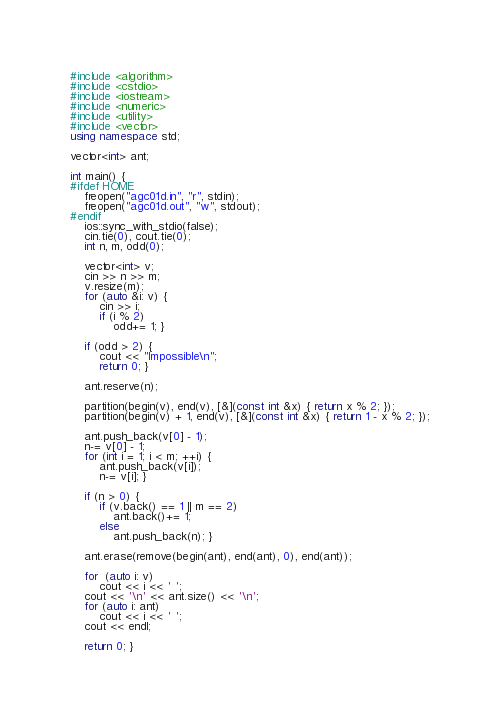Convert code to text. <code><loc_0><loc_0><loc_500><loc_500><_C++_>#include <algorithm>
#include <cstdio>
#include <iostream>
#include <numeric>
#include <utility>
#include <vector>
using namespace std;

vector<int> ant;

int main() {
#ifdef HOME
	freopen("agc01d.in", "r", stdin);
	freopen("agc01d.out", "w", stdout);
#endif
	ios::sync_with_stdio(false);
	cin.tie(0), cout.tie(0);
	int n, m, odd(0);

	vector<int> v;
	cin >> n >> m;
	v.resize(m);
	for (auto &i: v) {
		cin >> i;
		if (i % 2)
			odd+= 1; }

	if (odd > 2) {
		cout << "Impossible\n";
		return 0; }

	ant.reserve(n);

	partition(begin(v), end(v), [&](const int &x) { return x % 2; });
	partition(begin(v) + 1, end(v), [&](const int &x) { return 1 - x % 2; });

	ant.push_back(v[0] - 1);
	n-= v[0] - 1;
	for (int i = 1; i < m; ++i) {
		ant.push_back(v[i]);
		n-= v[i]; }

	if (n > 0) {
		if (v.back() == 1 || m == 2)
			ant.back()+= 1;
		else
			ant.push_back(n); }

	ant.erase(remove(begin(ant), end(ant), 0), end(ant));

	for  (auto i: v)
		cout << i << ' ';
	cout << '\n' << ant.size() << '\n';
	for (auto i: ant)
		cout << i << ' ';
	cout << endl;

	return 0; }
</code> 